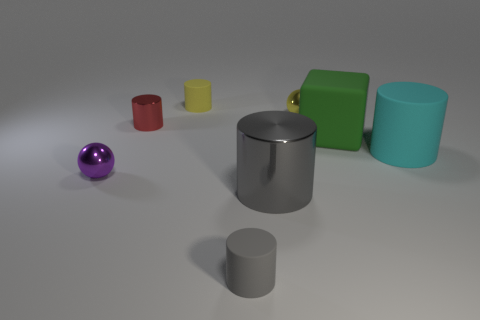Can you tell me about the lighting in the scene? Where could the light source be? The lighting in this scene appears to be soft and diffused, suggesting an overhead light source that is not directly visible. The shadows are quite subtle and fall to the right of the objects, indicating that the light source is somewhat to the left of the scene. 